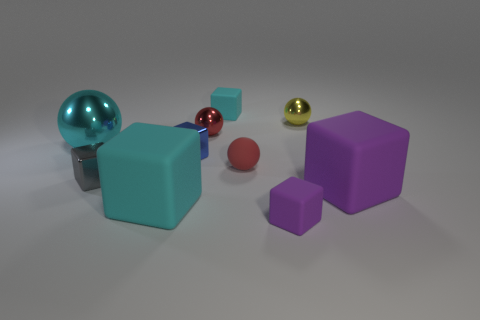Subtract all cyan cubes. How many cubes are left? 4 Subtract all small cyan cubes. How many cubes are left? 5 Subtract all blue cubes. Subtract all yellow cylinders. How many cubes are left? 5 Subtract all blocks. How many objects are left? 4 Add 7 tiny red matte things. How many tiny red matte things are left? 8 Add 7 purple rubber blocks. How many purple rubber blocks exist? 9 Subtract 1 purple blocks. How many objects are left? 9 Subtract all purple cubes. Subtract all yellow spheres. How many objects are left? 7 